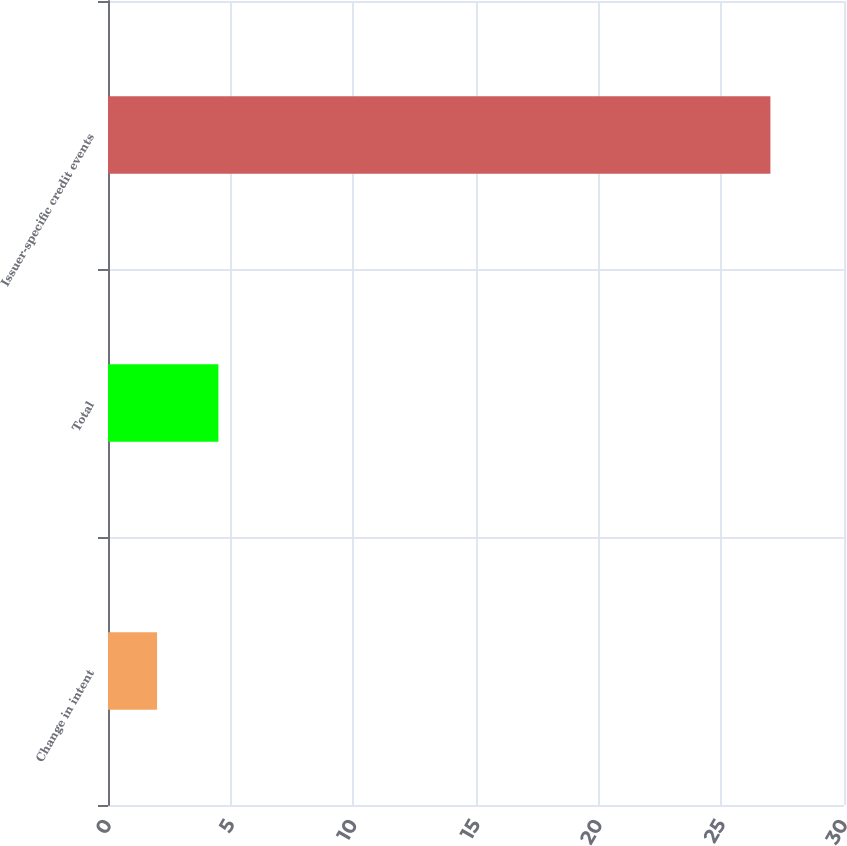Convert chart. <chart><loc_0><loc_0><loc_500><loc_500><bar_chart><fcel>Change in intent<fcel>Total<fcel>Issuer-specific credit events<nl><fcel>2<fcel>4.5<fcel>27<nl></chart> 